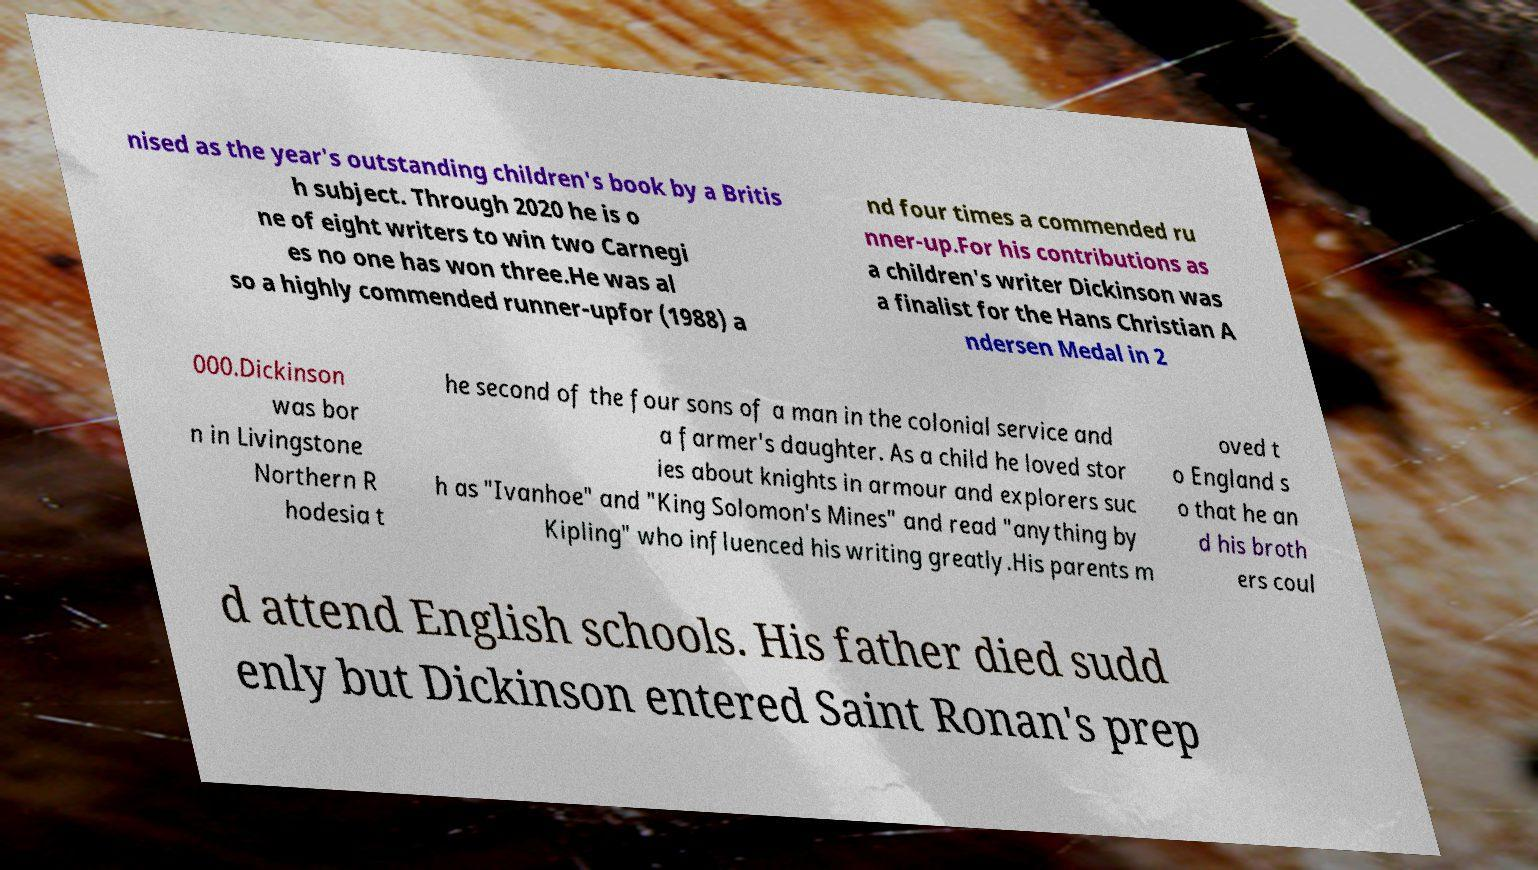For documentation purposes, I need the text within this image transcribed. Could you provide that? nised as the year's outstanding children's book by a Britis h subject. Through 2020 he is o ne of eight writers to win two Carnegi es no one has won three.He was al so a highly commended runner-upfor (1988) a nd four times a commended ru nner-up.For his contributions as a children's writer Dickinson was a finalist for the Hans Christian A ndersen Medal in 2 000.Dickinson was bor n in Livingstone Northern R hodesia t he second of the four sons of a man in the colonial service and a farmer's daughter. As a child he loved stor ies about knights in armour and explorers suc h as "Ivanhoe" and "King Solomon's Mines" and read "anything by Kipling" who influenced his writing greatly.His parents m oved t o England s o that he an d his broth ers coul d attend English schools. His father died sudd enly but Dickinson entered Saint Ronan's prep 